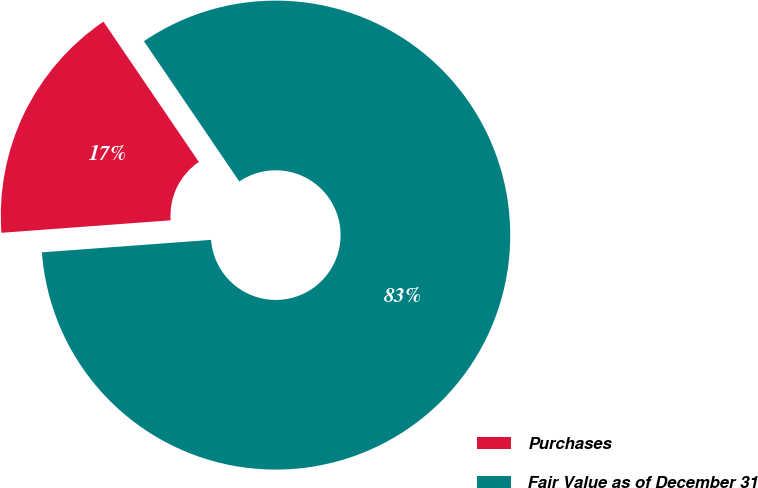Convert chart to OTSL. <chart><loc_0><loc_0><loc_500><loc_500><pie_chart><fcel>Purchases<fcel>Fair Value as of December 31<nl><fcel>16.67%<fcel>83.33%<nl></chart> 